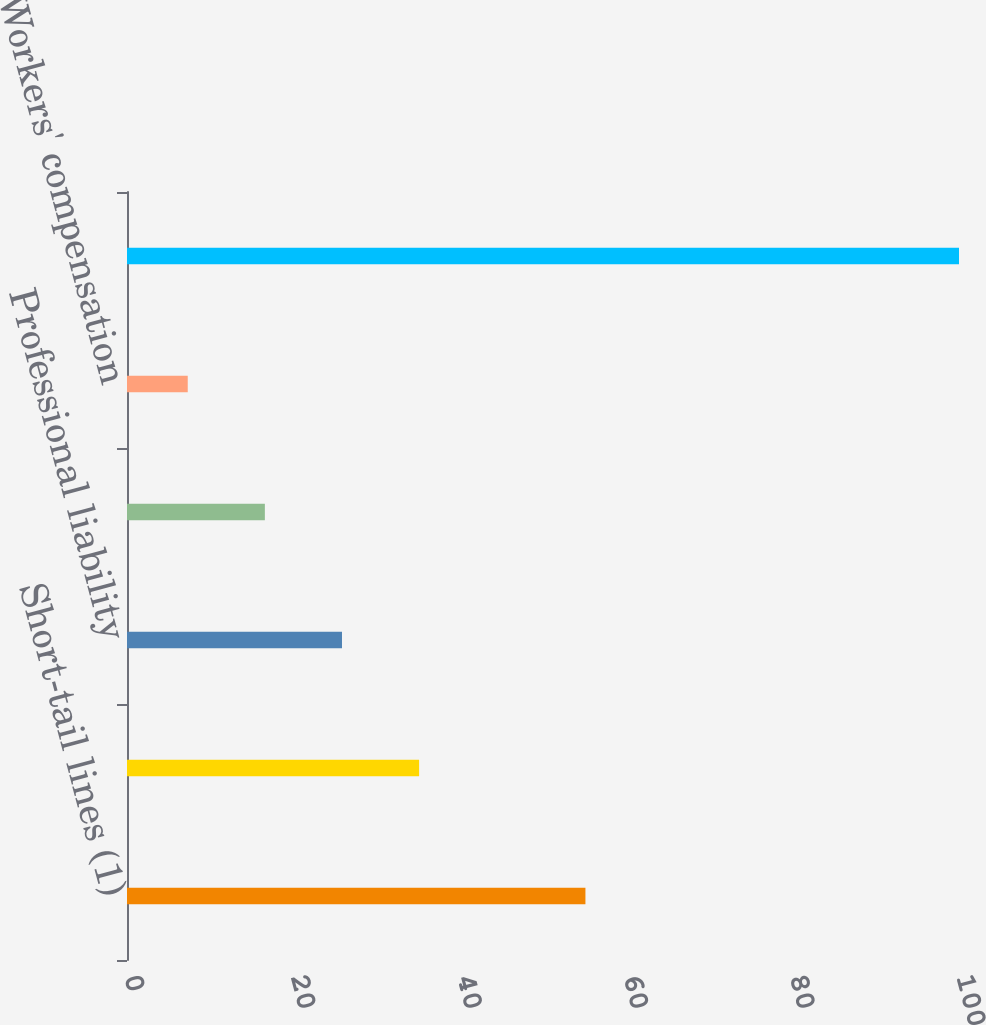Convert chart to OTSL. <chart><loc_0><loc_0><loc_500><loc_500><bar_chart><fcel>Short-tail lines (1)<fcel>Commercial auto<fcel>Professional liability<fcel>Other liability<fcel>Workers' compensation<fcel>Total<nl><fcel>55.1<fcel>35.11<fcel>25.84<fcel>16.57<fcel>7.3<fcel>100<nl></chart> 